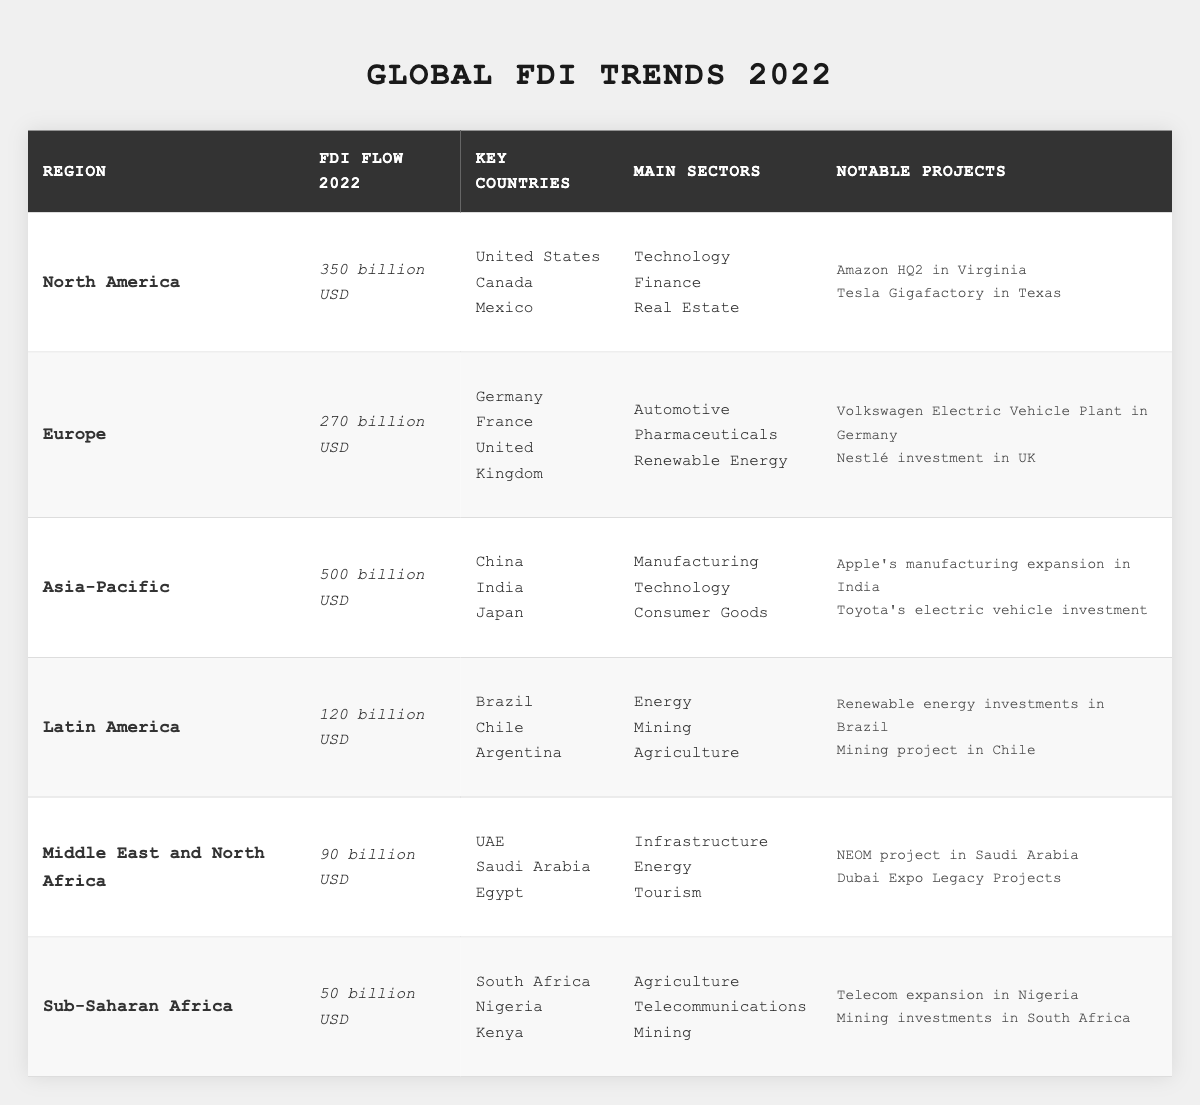What was the FDI flow for Asia-Pacific in 2022? The table shows the FDI flow for Asia-Pacific explicitly listed as "500 billion USD."
Answer: 500 billion USD Which region had the lowest FDI flow in 2022? By comparing the FDI flows listed, Sub-Saharan Africa has the lowest FDI flow at "50 billion USD."
Answer: Sub-Saharan Africa How many key countries are listed for Europe? The table lists three key countries for Europe: Germany, France, and the United Kingdom. Therefore, there are three key countries.
Answer: 3 What are the main sectors of FDI in Latin America? The table indicates that the main sectors for Latin America are Energy, Mining, and Agriculture.
Answer: Energy, Mining, Agriculture Which region had the highest FDI flow and by how much more than the region with the second highest? Asia-Pacific had the highest FDI flow at "500 billion USD," while North America had the second highest at "350 billion USD." The difference is 500 - 350 = 150 billion USD.
Answer: 150 billion USD Is the notable project "NEOM project" related to the region of North America? The notable project "NEOM project" is mentioned under the Middle East and North Africa region, so it is not related to North America.
Answer: No List the notable projects for Europe. The notable projects under Europe are "Volkswagen Electric Vehicle Plant in Germany" and "Nestlé investment in UK."
Answer: Volkswagen Electric Vehicle Plant in Germany, Nestlé investment in UK How many main sectors are identified in the Asia-Pacific region? The Asia-Pacific region lists three main sectors: Manufacturing, Technology, and Consumer Goods, indicating there are three sectors.
Answer: 3 If you combine the FDI flows of Latin America and Sub-Saharan Africa, what will be the total? Latin America has "120 billion USD" and Sub-Saharan Africa has "50 billion USD." Adding them gives 120 + 50 = 170 billion USD.
Answer: 170 billion USD Are the key countries for North America and Europe the same? The key countries for North America include the United States, Canada, and Mexico, while for Europe they include Germany, France, and the United Kingdom. Since these lists are different, the answer is no.
Answer: No 